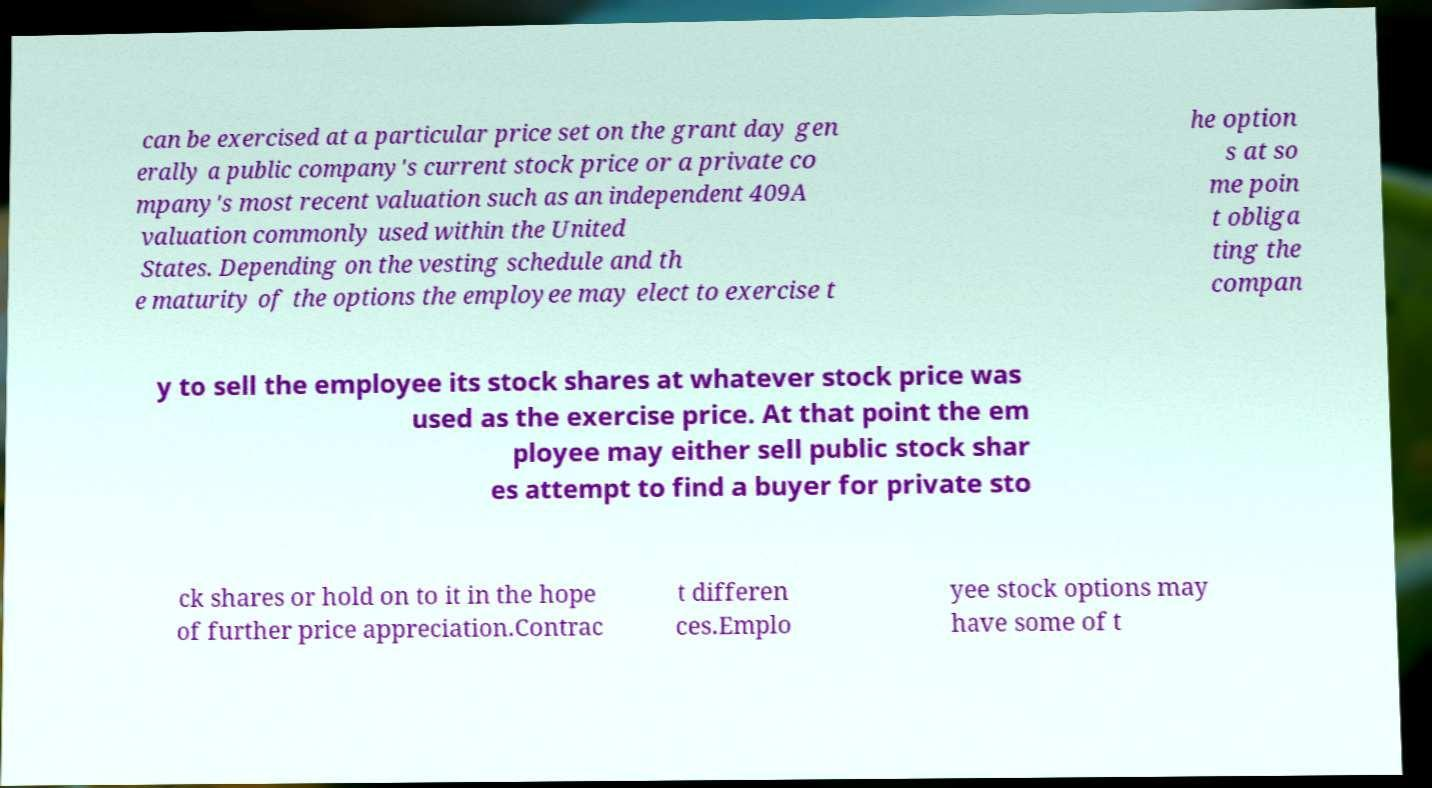Please read and relay the text visible in this image. What does it say? can be exercised at a particular price set on the grant day gen erally a public company's current stock price or a private co mpany's most recent valuation such as an independent 409A valuation commonly used within the United States. Depending on the vesting schedule and th e maturity of the options the employee may elect to exercise t he option s at so me poin t obliga ting the compan y to sell the employee its stock shares at whatever stock price was used as the exercise price. At that point the em ployee may either sell public stock shar es attempt to find a buyer for private sto ck shares or hold on to it in the hope of further price appreciation.Contrac t differen ces.Emplo yee stock options may have some of t 